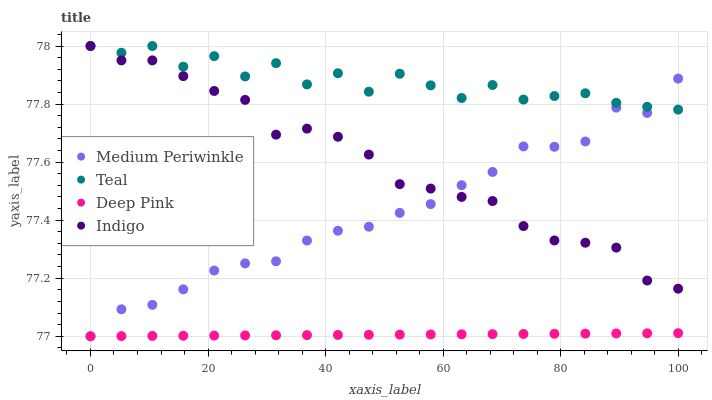Does Deep Pink have the minimum area under the curve?
Answer yes or no. Yes. Does Teal have the maximum area under the curve?
Answer yes or no. Yes. Does Medium Periwinkle have the minimum area under the curve?
Answer yes or no. No. Does Medium Periwinkle have the maximum area under the curve?
Answer yes or no. No. Is Deep Pink the smoothest?
Answer yes or no. Yes. Is Teal the roughest?
Answer yes or no. Yes. Is Medium Periwinkle the smoothest?
Answer yes or no. No. Is Medium Periwinkle the roughest?
Answer yes or no. No. Does Deep Pink have the lowest value?
Answer yes or no. Yes. Does Teal have the lowest value?
Answer yes or no. No. Does Teal have the highest value?
Answer yes or no. Yes. Does Medium Periwinkle have the highest value?
Answer yes or no. No. Is Deep Pink less than Indigo?
Answer yes or no. Yes. Is Indigo greater than Deep Pink?
Answer yes or no. Yes. Does Indigo intersect Teal?
Answer yes or no. Yes. Is Indigo less than Teal?
Answer yes or no. No. Is Indigo greater than Teal?
Answer yes or no. No. Does Deep Pink intersect Indigo?
Answer yes or no. No. 